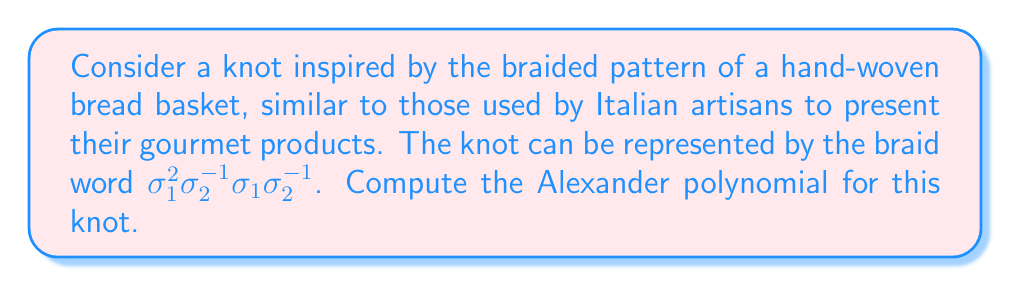Could you help me with this problem? To compute the Alexander polynomial for this knot, we'll follow these steps:

1. Convert the braid word to a braid matrix:
The braid word $\sigma_1^2\sigma_2^{-1}\sigma_1\sigma_2^{-1}$ corresponds to a 3-strand braid. We'll use the Burau representation to convert it to a matrix.

For $\sigma_1$: $\begin{pmatrix} -t & 1 & 0 \\ 0 & 1 & 0 \\ 0 & 0 & 1 \end{pmatrix}$
For $\sigma_2$: $\begin{pmatrix} 1 & 0 & 0 \\ 0 & -t & 1 \\ 0 & 0 & 1 \end{pmatrix}$

2. Multiply the matrices:
$$B = \begin{pmatrix} -t & 1 & 0 \\ 0 & 1 & 0 \\ 0 & 0 & 1 \end{pmatrix}^2 \cdot \begin{pmatrix} 1 & 0 & 0 \\ 0 & -t^{-1} & t^{-1} \\ 0 & 1 & 0 \end{pmatrix} \cdot \begin{pmatrix} -t & 1 & 0 \\ 0 & 1 & 0 \\ 0 & 0 & 1 \end{pmatrix} \cdot \begin{pmatrix} 1 & 0 & 0 \\ 0 & -t^{-1} & t^{-1} \\ 0 & 1 & 0 \end{pmatrix}$$

3. Compute the characteristic polynomial:
$$\det(xI - B) = \det\begin{pmatrix} x+t^2 & -t & 0 \\ t^2 & x-1 & -t \\ 0 & 1 & x \end{pmatrix}$$

4. Expand the determinant:
$$(x+t^2)(x-1)x - (-t)(t^2)x - 0 = x^3 + (t^2-1)x^2 - t^2x$$

5. Normalize the polynomial:
Divide by the highest power of $x$ and substitute $t$ for $x$:

$$\Delta(t) = 1 + (t^2-1)t^{-1} - t^2t^{-2} = t + t^{-1} - 1$$

This is the Alexander polynomial for the given knot.
Answer: $\Delta(t) = t + t^{-1} - 1$ 